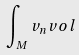Convert formula to latex. <formula><loc_0><loc_0><loc_500><loc_500>\int _ { M } v _ { n } v o l</formula> 